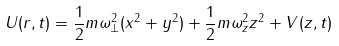<formula> <loc_0><loc_0><loc_500><loc_500>U ( r , t ) = \frac { 1 } { 2 } m \omega ^ { 2 } _ { \perp } ( x ^ { 2 } + y ^ { 2 } ) + \frac { 1 } { 2 } m \omega ^ { 2 } _ { z } z ^ { 2 } + V ( z , t )</formula> 